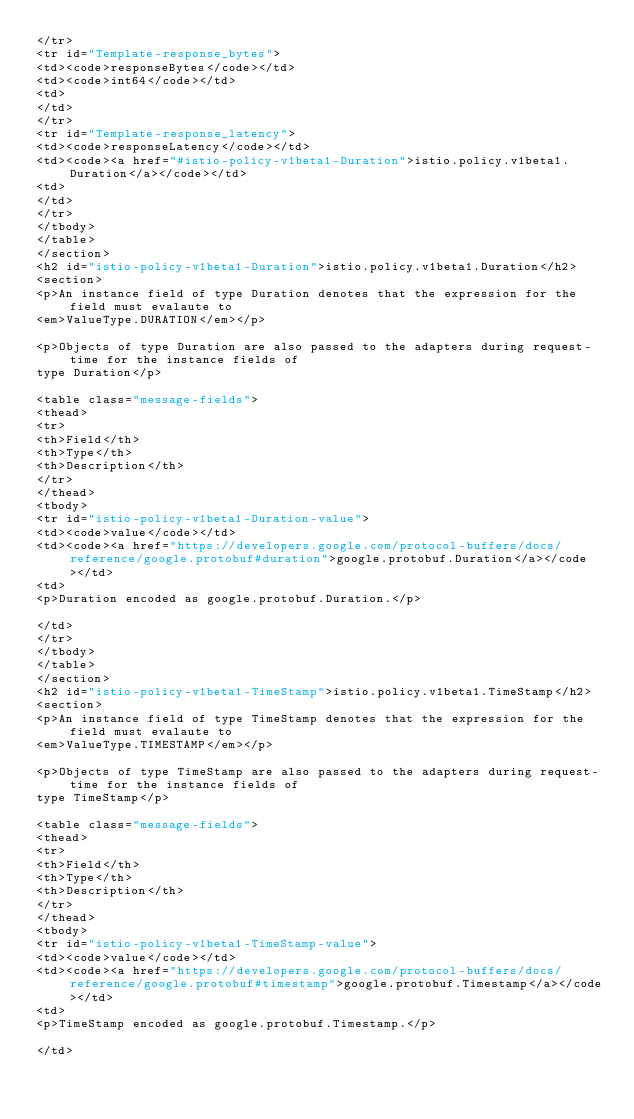<code> <loc_0><loc_0><loc_500><loc_500><_HTML_></tr>
<tr id="Template-response_bytes">
<td><code>responseBytes</code></td>
<td><code>int64</code></td>
<td>
</td>
</tr>
<tr id="Template-response_latency">
<td><code>responseLatency</code></td>
<td><code><a href="#istio-policy-v1beta1-Duration">istio.policy.v1beta1.Duration</a></code></td>
<td>
</td>
</tr>
</tbody>
</table>
</section>
<h2 id="istio-policy-v1beta1-Duration">istio.policy.v1beta1.Duration</h2>
<section>
<p>An instance field of type Duration denotes that the expression for the field must evalaute to
<em>ValueType.DURATION</em></p>

<p>Objects of type Duration are also passed to the adapters during request-time for the instance fields of
type Duration</p>

<table class="message-fields">
<thead>
<tr>
<th>Field</th>
<th>Type</th>
<th>Description</th>
</tr>
</thead>
<tbody>
<tr id="istio-policy-v1beta1-Duration-value">
<td><code>value</code></td>
<td><code><a href="https://developers.google.com/protocol-buffers/docs/reference/google.protobuf#duration">google.protobuf.Duration</a></code></td>
<td>
<p>Duration encoded as google.protobuf.Duration.</p>

</td>
</tr>
</tbody>
</table>
</section>
<h2 id="istio-policy-v1beta1-TimeStamp">istio.policy.v1beta1.TimeStamp</h2>
<section>
<p>An instance field of type TimeStamp denotes that the expression for the field must evalaute to
<em>ValueType.TIMESTAMP</em></p>

<p>Objects of type TimeStamp are also passed to the adapters during request-time for the instance fields of
type TimeStamp</p>

<table class="message-fields">
<thead>
<tr>
<th>Field</th>
<th>Type</th>
<th>Description</th>
</tr>
</thead>
<tbody>
<tr id="istio-policy-v1beta1-TimeStamp-value">
<td><code>value</code></td>
<td><code><a href="https://developers.google.com/protocol-buffers/docs/reference/google.protobuf#timestamp">google.protobuf.Timestamp</a></code></td>
<td>
<p>TimeStamp encoded as google.protobuf.Timestamp.</p>

</td></code> 